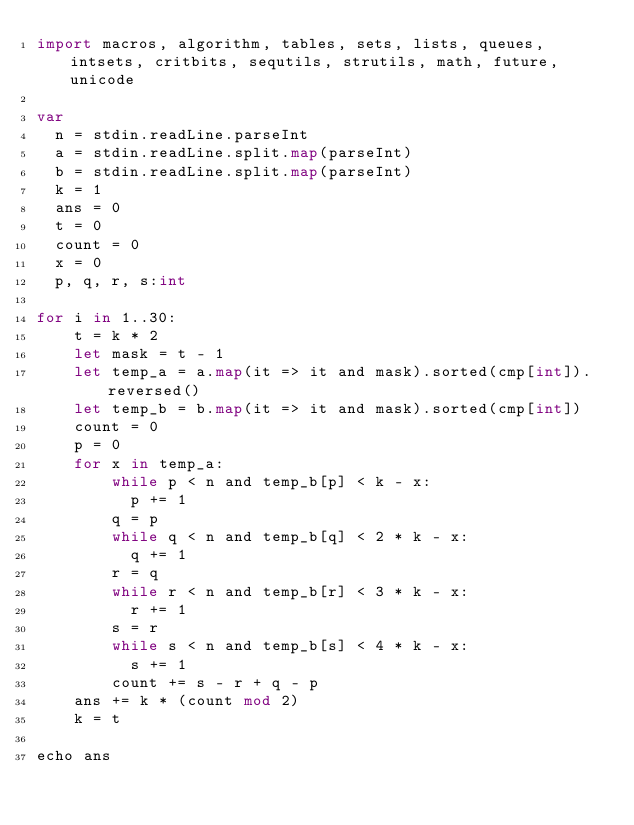Convert code to text. <code><loc_0><loc_0><loc_500><loc_500><_Nim_>import macros, algorithm, tables, sets, lists, queues, intsets, critbits, sequtils, strutils, math, future, unicode

var
  n = stdin.readLine.parseInt
  a = stdin.readLine.split.map(parseInt)
  b = stdin.readLine.split.map(parseInt)
  k = 1
  ans = 0
  t = 0
  count = 0
  x = 0
  p, q, r, s:int

for i in 1..30:
    t = k * 2
    let mask = t - 1
    let temp_a = a.map(it => it and mask).sorted(cmp[int]).reversed()
    let temp_b = b.map(it => it and mask).sorted(cmp[int])
    count = 0
    p = 0
    for x in temp_a:
        while p < n and temp_b[p] < k - x:
          p += 1
        q = p
        while q < n and temp_b[q] < 2 * k - x:
          q += 1
        r = q
        while r < n and temp_b[r] < 3 * k - x:
          r += 1
        s = r
        while s < n and temp_b[s] < 4 * k - x:
          s += 1
        count += s - r + q - p
    ans += k * (count mod 2)
    k = t

echo ans
</code> 